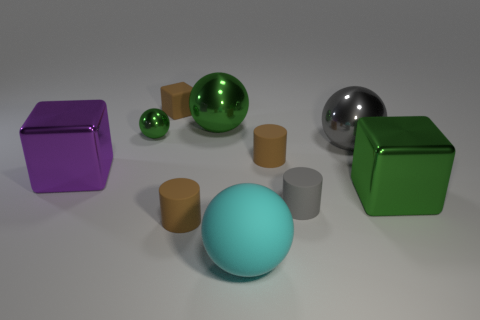Are there any gray objects right of the green metallic block?
Your response must be concise. No. The thing that is to the right of the tiny brown cube and behind the small sphere is what color?
Provide a short and direct response. Green. How big is the rubber cylinder that is on the right side of the matte cylinder behind the large green metallic block?
Your response must be concise. Small. How many balls are either small matte objects or large gray metallic things?
Your response must be concise. 1. What color is the ball that is the same size as the brown rubber cube?
Make the answer very short. Green. The big metallic object that is in front of the shiny block on the left side of the tiny green object is what shape?
Provide a short and direct response. Cube. Does the gray thing that is in front of the purple shiny block have the same size as the purple block?
Offer a very short reply. No. How many other things are made of the same material as the gray sphere?
Your answer should be very brief. 4. How many gray objects are cylinders or blocks?
Provide a short and direct response. 1. What is the size of the other ball that is the same color as the small metal ball?
Your answer should be very brief. Large. 